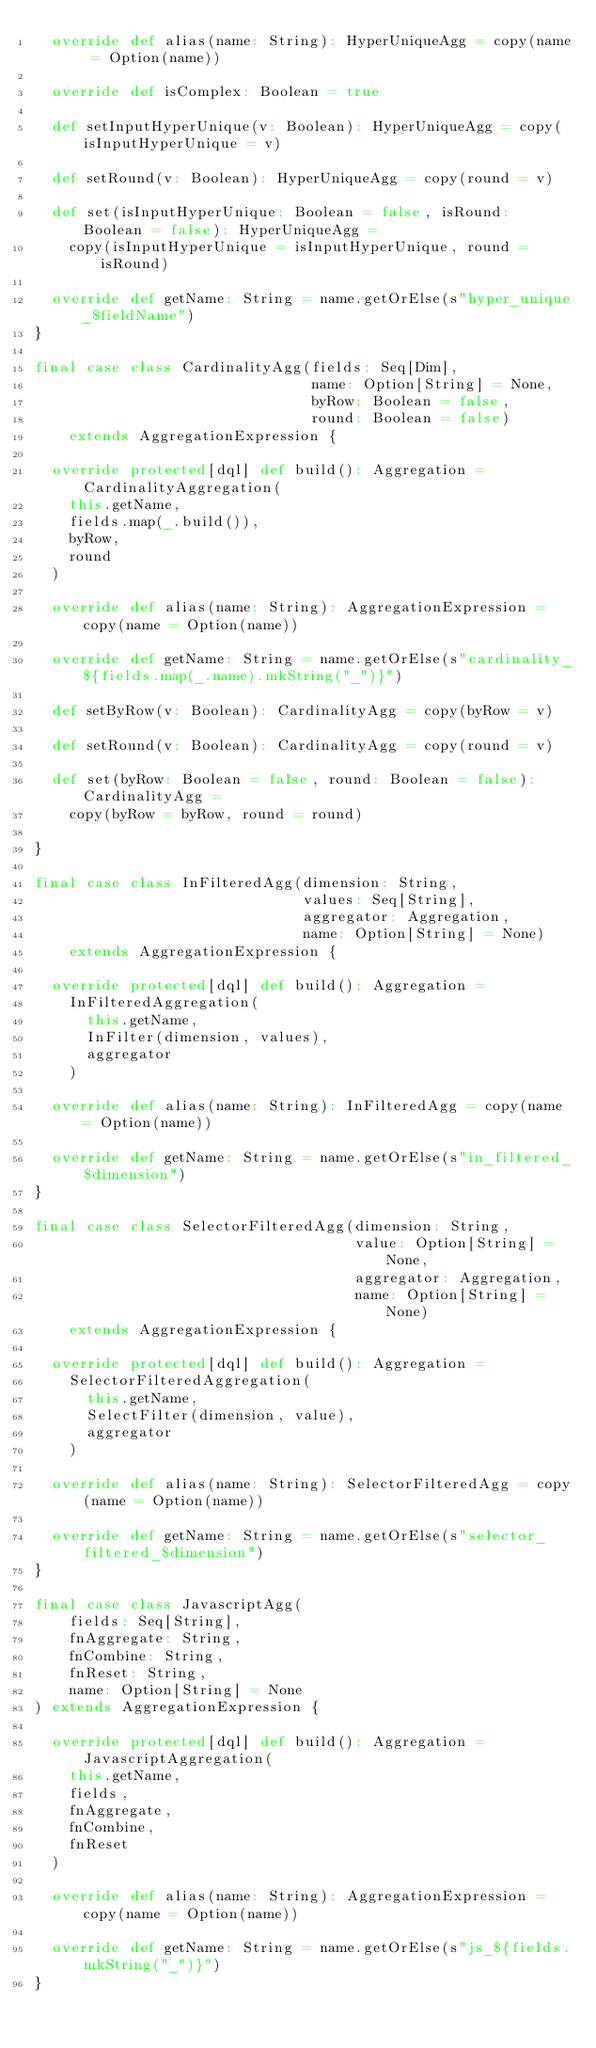<code> <loc_0><loc_0><loc_500><loc_500><_Scala_>  override def alias(name: String): HyperUniqueAgg = copy(name = Option(name))

  override def isComplex: Boolean = true

  def setInputHyperUnique(v: Boolean): HyperUniqueAgg = copy(isInputHyperUnique = v)

  def setRound(v: Boolean): HyperUniqueAgg = copy(round = v)

  def set(isInputHyperUnique: Boolean = false, isRound: Boolean = false): HyperUniqueAgg =
    copy(isInputHyperUnique = isInputHyperUnique, round = isRound)

  override def getName: String = name.getOrElse(s"hyper_unique_$fieldName")
}

final case class CardinalityAgg(fields: Seq[Dim],
                                name: Option[String] = None,
                                byRow: Boolean = false,
                                round: Boolean = false)
    extends AggregationExpression {

  override protected[dql] def build(): Aggregation = CardinalityAggregation(
    this.getName,
    fields.map(_.build()),
    byRow,
    round
  )

  override def alias(name: String): AggregationExpression = copy(name = Option(name))

  override def getName: String = name.getOrElse(s"cardinality_${fields.map(_.name).mkString("_")}")

  def setByRow(v: Boolean): CardinalityAgg = copy(byRow = v)

  def setRound(v: Boolean): CardinalityAgg = copy(round = v)

  def set(byRow: Boolean = false, round: Boolean = false): CardinalityAgg =
    copy(byRow = byRow, round = round)

}

final case class InFilteredAgg(dimension: String,
                               values: Seq[String],
                               aggregator: Aggregation,
                               name: Option[String] = None)
    extends AggregationExpression {

  override protected[dql] def build(): Aggregation =
    InFilteredAggregation(
      this.getName,
      InFilter(dimension, values),
      aggregator
    )

  override def alias(name: String): InFilteredAgg = copy(name = Option(name))

  override def getName: String = name.getOrElse(s"in_filtered_$dimension")
}

final case class SelectorFilteredAgg(dimension: String,
                                     value: Option[String] = None,
                                     aggregator: Aggregation,
                                     name: Option[String] = None)
    extends AggregationExpression {

  override protected[dql] def build(): Aggregation =
    SelectorFilteredAggregation(
      this.getName,
      SelectFilter(dimension, value),
      aggregator
    )

  override def alias(name: String): SelectorFilteredAgg = copy(name = Option(name))

  override def getName: String = name.getOrElse(s"selector_filtered_$dimension")
}

final case class JavascriptAgg(
    fields: Seq[String],
    fnAggregate: String,
    fnCombine: String,
    fnReset: String,
    name: Option[String] = None
) extends AggregationExpression {

  override protected[dql] def build(): Aggregation = JavascriptAggregation(
    this.getName,
    fields,
    fnAggregate,
    fnCombine,
    fnReset
  )

  override def alias(name: String): AggregationExpression = copy(name = Option(name))

  override def getName: String = name.getOrElse(s"js_${fields.mkString("_")}")
}
</code> 